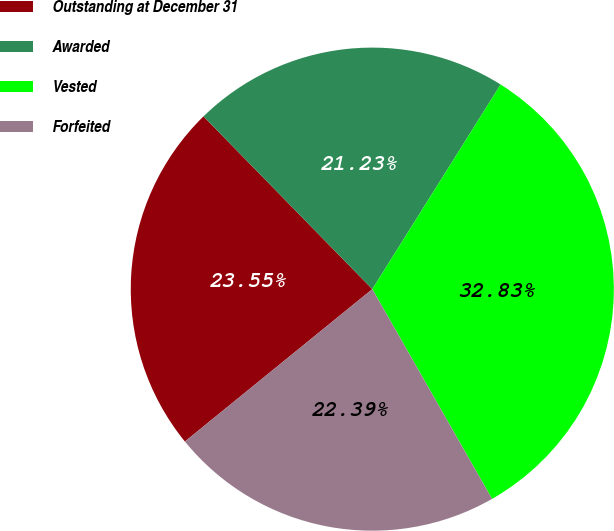Convert chart to OTSL. <chart><loc_0><loc_0><loc_500><loc_500><pie_chart><fcel>Outstanding at December 31<fcel>Awarded<fcel>Vested<fcel>Forfeited<nl><fcel>23.55%<fcel>21.23%<fcel>32.83%<fcel>22.39%<nl></chart> 